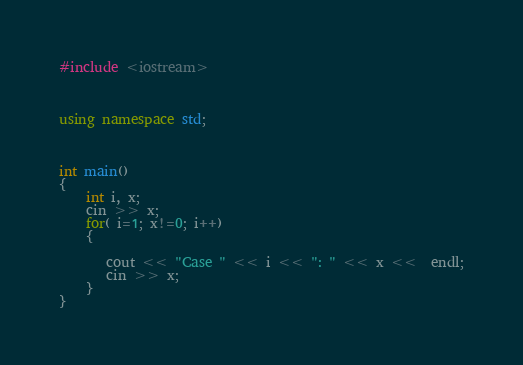Convert code to text. <code><loc_0><loc_0><loc_500><loc_500><_C++_>#include <iostream>

 

using namespace std;

 

int main() 
{
    int i, x;
    cin >> x;
    for( i=1; x!=0; i++)
    {
    
       cout << "Case " << i << ": " << x <<  endl;
       cin >> x;
    }
}
</code> 